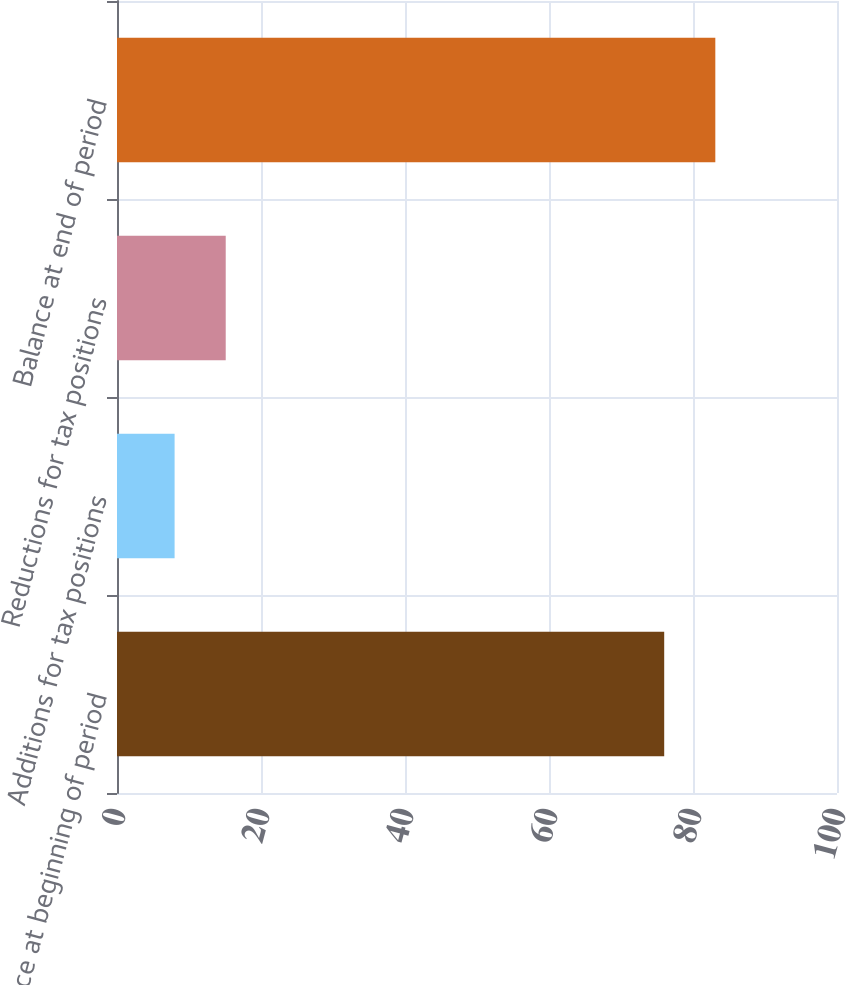<chart> <loc_0><loc_0><loc_500><loc_500><bar_chart><fcel>Balance at beginning of period<fcel>Additions for tax positions<fcel>Reductions for tax positions<fcel>Balance at end of period<nl><fcel>76<fcel>8<fcel>15.1<fcel>83.1<nl></chart> 